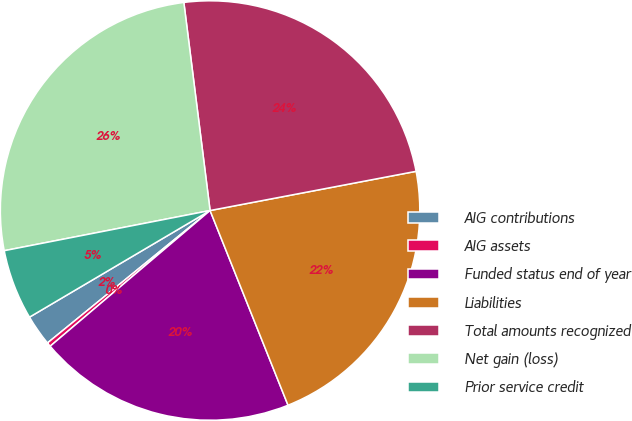Convert chart to OTSL. <chart><loc_0><loc_0><loc_500><loc_500><pie_chart><fcel>AIG contributions<fcel>AIG assets<fcel>Funded status end of year<fcel>Liabilities<fcel>Total amounts recognized<fcel>Net gain (loss)<fcel>Prior service credit<nl><fcel>2.39%<fcel>0.32%<fcel>19.86%<fcel>21.93%<fcel>24.0%<fcel>26.07%<fcel>5.42%<nl></chart> 